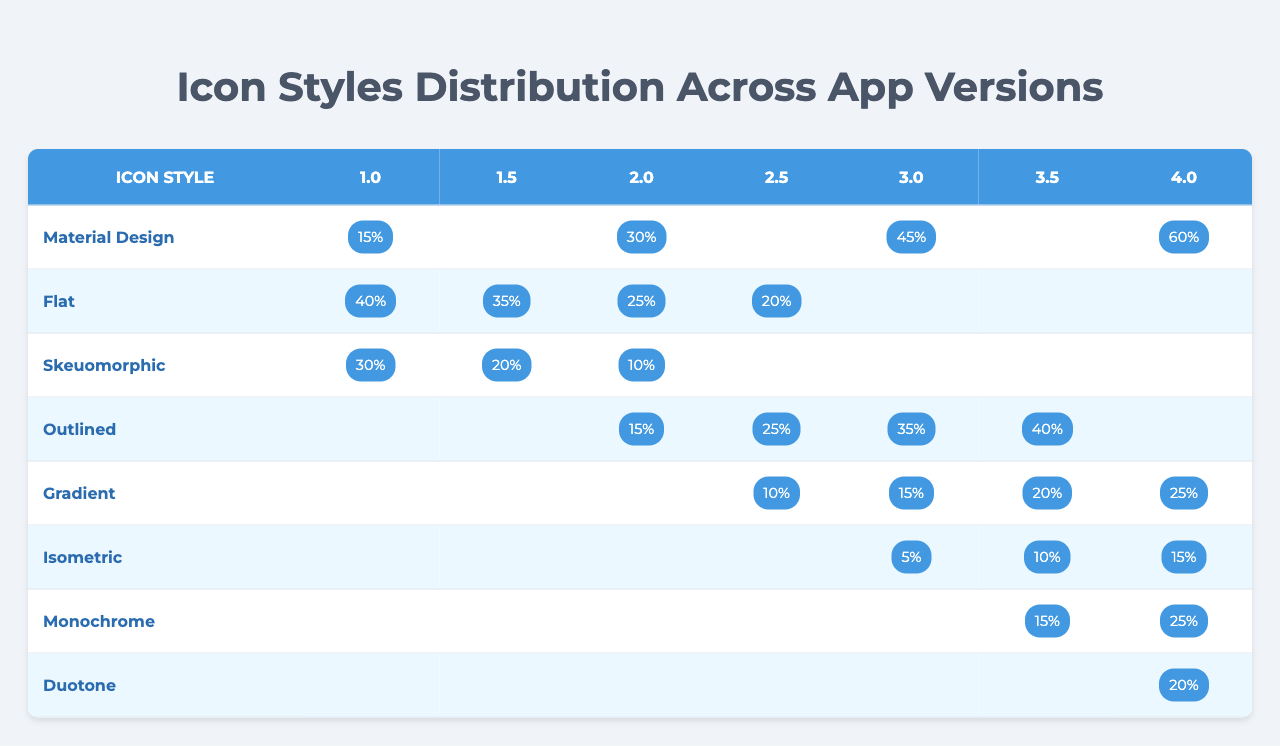What is the distribution of "Gradient" icon style in version 4.0? The "Gradient" icon style shows a distribution value of 25% in the 4.0 column of the table.
Answer: 25% Which app version has the highest distribution of "Material Design"? The highest distribution for "Material Design" is in version 4.0 with a value of 60%.
Answer: 60% What is the distribution percentage for "Isometric" icon style in version 3.5? The table shows no distribution percentage for "Isometric" in version 3.5, indicating that this style was not used in that version.
Answer: 0% What is the total distribution of "Flat" icon style across all versions shown? Adding the distribution percentages: 40 + 35 + 25 + 20 = 120. The total distribution for "Flat" is 120%.
Answer: 120% Is there any app version that shows a distribution value for "Skeuomorphic"? Yes, "Skeuomorphic" has distributions in versions 1.0 (30%), 1.5 (20%), and 2.0 (10%).
Answer: Yes What is the average distribution of "Outlined" icon style across available versions? The distribution percentages for "Outlined" are 15, 25, 35, and 40. The total is 15 + 25 + 35 + 40 = 115, and there are 4 data points, so 115/4 = 28.75.
Answer: 28.75 Which icon style had the least representation in version 3.0? "Isometric" icon style had the least representation with a distribution value of 5% in version 3.0.
Answer: 5% How does the distribution percentage of "Monochrome" in version 4.0 compare to that of "Duotone"? "Monochrome" in version 4.0 has a distribution of 25%, while "Duotone" has 20%, indicating that "Monochrome" is higher by 5%.
Answer: Higher by 5% Which icon style did not appear in the app version 1.5? The "Outlined" icon style does not appear in version 1.5 based on the given distribution data.
Answer: Outlined Identify an icon style that has consistent distribution in two or more app versions. The "Gradient" icon style has consistent distribution values of 10% in both 2.5 and 3.0.
Answer: Gradient 